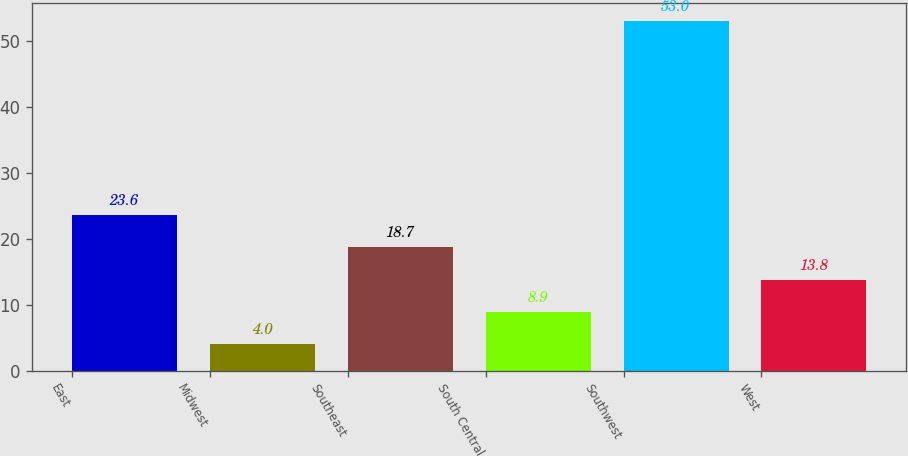Convert chart. <chart><loc_0><loc_0><loc_500><loc_500><bar_chart><fcel>East<fcel>Midwest<fcel>Southeast<fcel>South Central<fcel>Southwest<fcel>West<nl><fcel>23.6<fcel>4<fcel>18.7<fcel>8.9<fcel>53<fcel>13.8<nl></chart> 